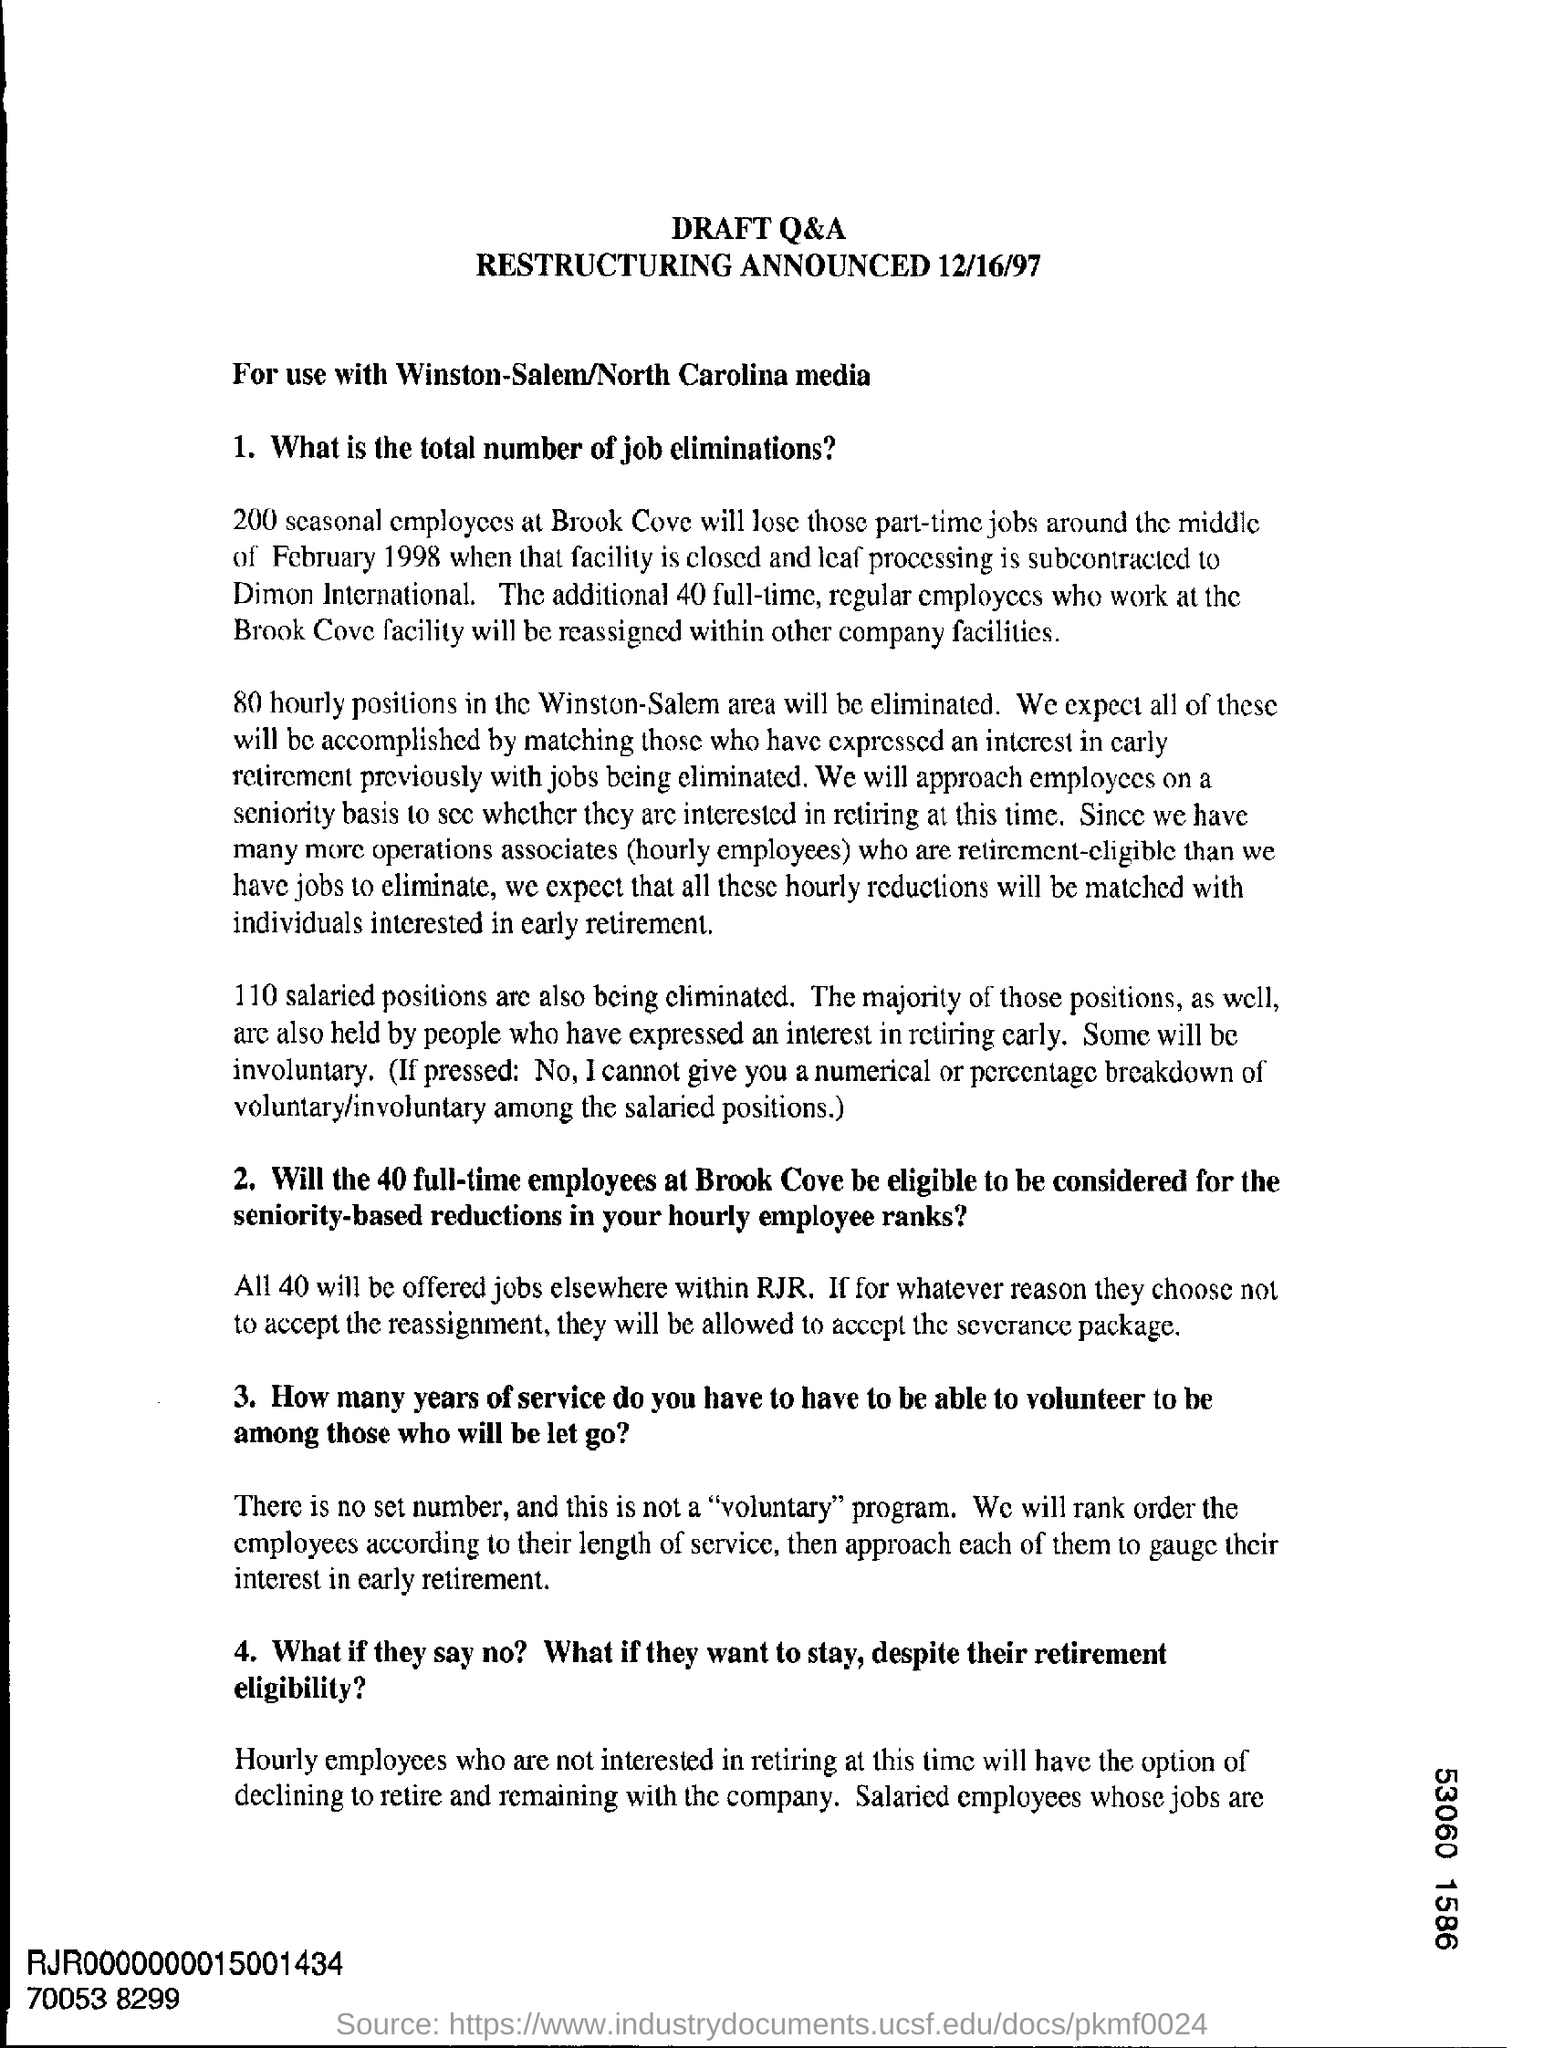Draw attention to some important aspects in this diagram. Approximately 200 seasonal employees are expected to lose their part-time jobs in mid-February 1998. The heading at the top of the page is 'Draft Q&A'. The restructuring was announced on December 16, 1997. 